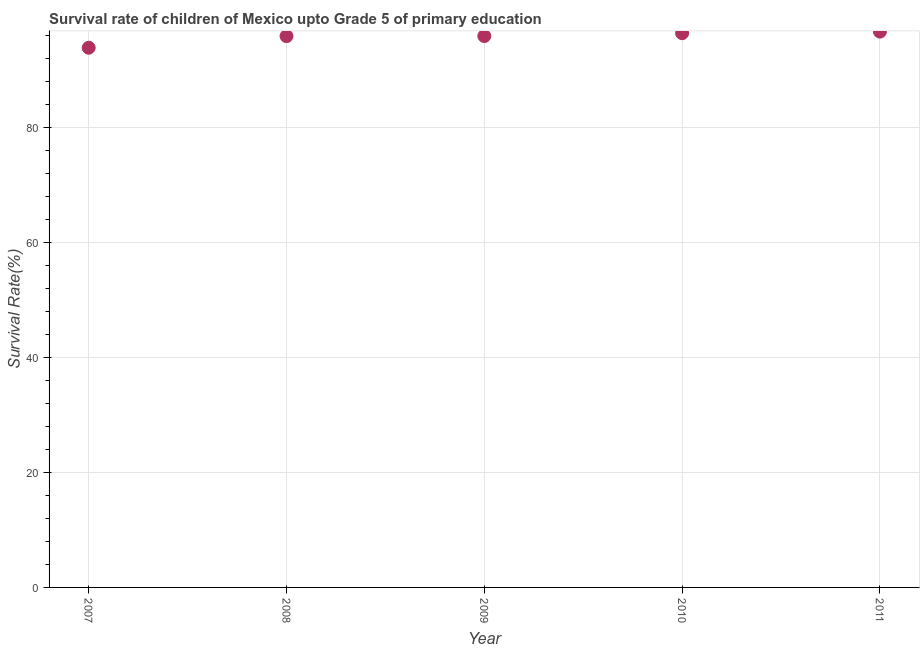What is the survival rate in 2011?
Give a very brief answer. 96.74. Across all years, what is the maximum survival rate?
Provide a succinct answer. 96.74. Across all years, what is the minimum survival rate?
Your response must be concise. 93.94. In which year was the survival rate maximum?
Make the answer very short. 2011. In which year was the survival rate minimum?
Your answer should be very brief. 2007. What is the sum of the survival rate?
Offer a very short reply. 479.07. What is the difference between the survival rate in 2007 and 2011?
Give a very brief answer. -2.81. What is the average survival rate per year?
Provide a short and direct response. 95.81. What is the median survival rate?
Keep it short and to the point. 95.97. Do a majority of the years between 2009 and 2011 (inclusive) have survival rate greater than 88 %?
Give a very brief answer. Yes. What is the ratio of the survival rate in 2008 to that in 2011?
Keep it short and to the point. 0.99. Is the survival rate in 2009 less than that in 2011?
Offer a very short reply. Yes. What is the difference between the highest and the second highest survival rate?
Your response must be concise. 0.27. Is the sum of the survival rate in 2009 and 2011 greater than the maximum survival rate across all years?
Give a very brief answer. Yes. What is the difference between the highest and the lowest survival rate?
Give a very brief answer. 2.81. Does the survival rate monotonically increase over the years?
Give a very brief answer. Yes. How many dotlines are there?
Make the answer very short. 1. How many years are there in the graph?
Your response must be concise. 5. Does the graph contain any zero values?
Offer a terse response. No. What is the title of the graph?
Make the answer very short. Survival rate of children of Mexico upto Grade 5 of primary education. What is the label or title of the X-axis?
Provide a succinct answer. Year. What is the label or title of the Y-axis?
Provide a short and direct response. Survival Rate(%). What is the Survival Rate(%) in 2007?
Provide a short and direct response. 93.94. What is the Survival Rate(%) in 2008?
Your answer should be very brief. 95.96. What is the Survival Rate(%) in 2009?
Your response must be concise. 95.97. What is the Survival Rate(%) in 2010?
Your answer should be very brief. 96.47. What is the Survival Rate(%) in 2011?
Your answer should be very brief. 96.74. What is the difference between the Survival Rate(%) in 2007 and 2008?
Your response must be concise. -2.02. What is the difference between the Survival Rate(%) in 2007 and 2009?
Provide a short and direct response. -2.03. What is the difference between the Survival Rate(%) in 2007 and 2010?
Provide a short and direct response. -2.53. What is the difference between the Survival Rate(%) in 2007 and 2011?
Make the answer very short. -2.81. What is the difference between the Survival Rate(%) in 2008 and 2009?
Provide a succinct answer. -0.01. What is the difference between the Survival Rate(%) in 2008 and 2010?
Your answer should be very brief. -0.51. What is the difference between the Survival Rate(%) in 2008 and 2011?
Ensure brevity in your answer.  -0.78. What is the difference between the Survival Rate(%) in 2009 and 2010?
Make the answer very short. -0.5. What is the difference between the Survival Rate(%) in 2009 and 2011?
Your answer should be very brief. -0.77. What is the difference between the Survival Rate(%) in 2010 and 2011?
Make the answer very short. -0.27. What is the ratio of the Survival Rate(%) in 2007 to that in 2008?
Ensure brevity in your answer.  0.98. What is the ratio of the Survival Rate(%) in 2007 to that in 2010?
Provide a short and direct response. 0.97. What is the ratio of the Survival Rate(%) in 2007 to that in 2011?
Give a very brief answer. 0.97. What is the ratio of the Survival Rate(%) in 2008 to that in 2010?
Your response must be concise. 0.99. What is the ratio of the Survival Rate(%) in 2010 to that in 2011?
Your answer should be compact. 1. 